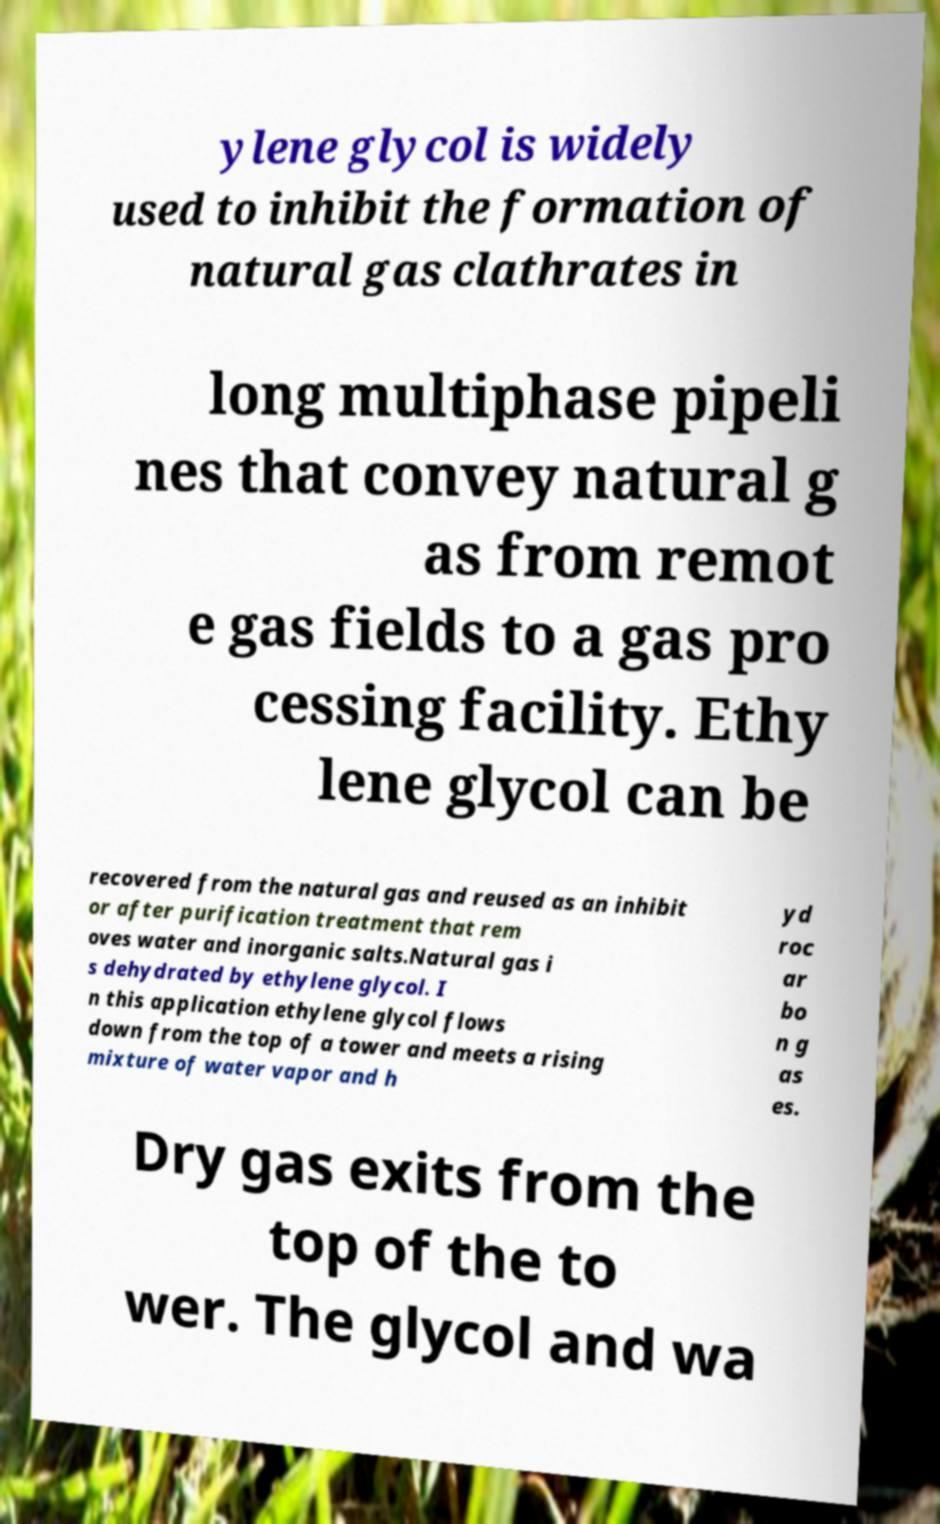There's text embedded in this image that I need extracted. Can you transcribe it verbatim? ylene glycol is widely used to inhibit the formation of natural gas clathrates in long multiphase pipeli nes that convey natural g as from remot e gas fields to a gas pro cessing facility. Ethy lene glycol can be recovered from the natural gas and reused as an inhibit or after purification treatment that rem oves water and inorganic salts.Natural gas i s dehydrated by ethylene glycol. I n this application ethylene glycol flows down from the top of a tower and meets a rising mixture of water vapor and h yd roc ar bo n g as es. Dry gas exits from the top of the to wer. The glycol and wa 